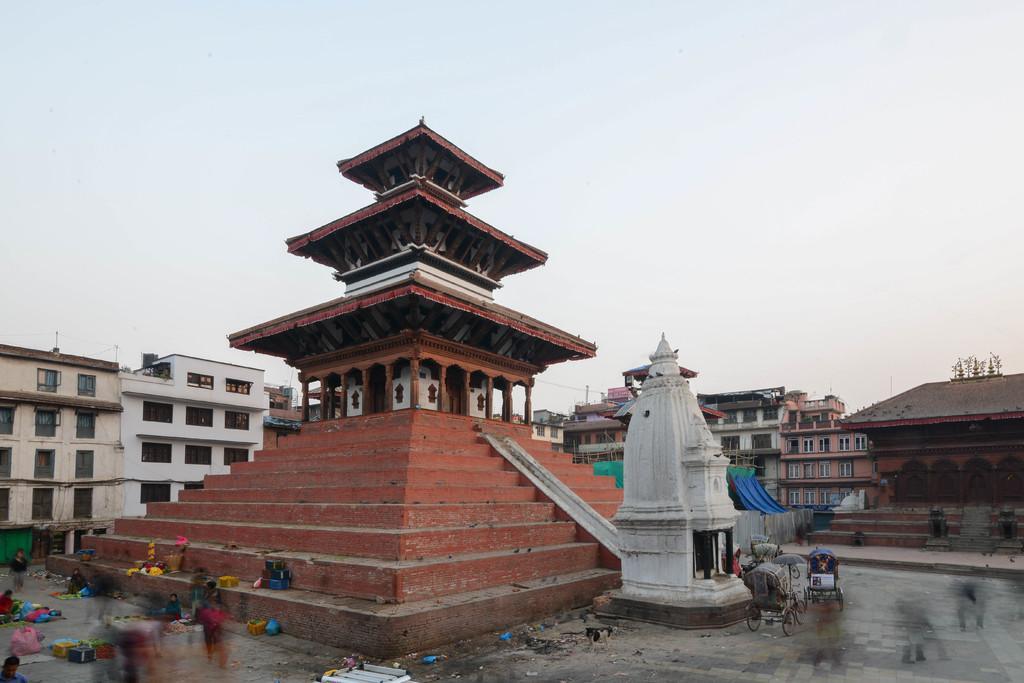Please provide a concise description of this image. In this image, we can see some stairs and there are some buildings, at the top there is a sky which is cloudy. 